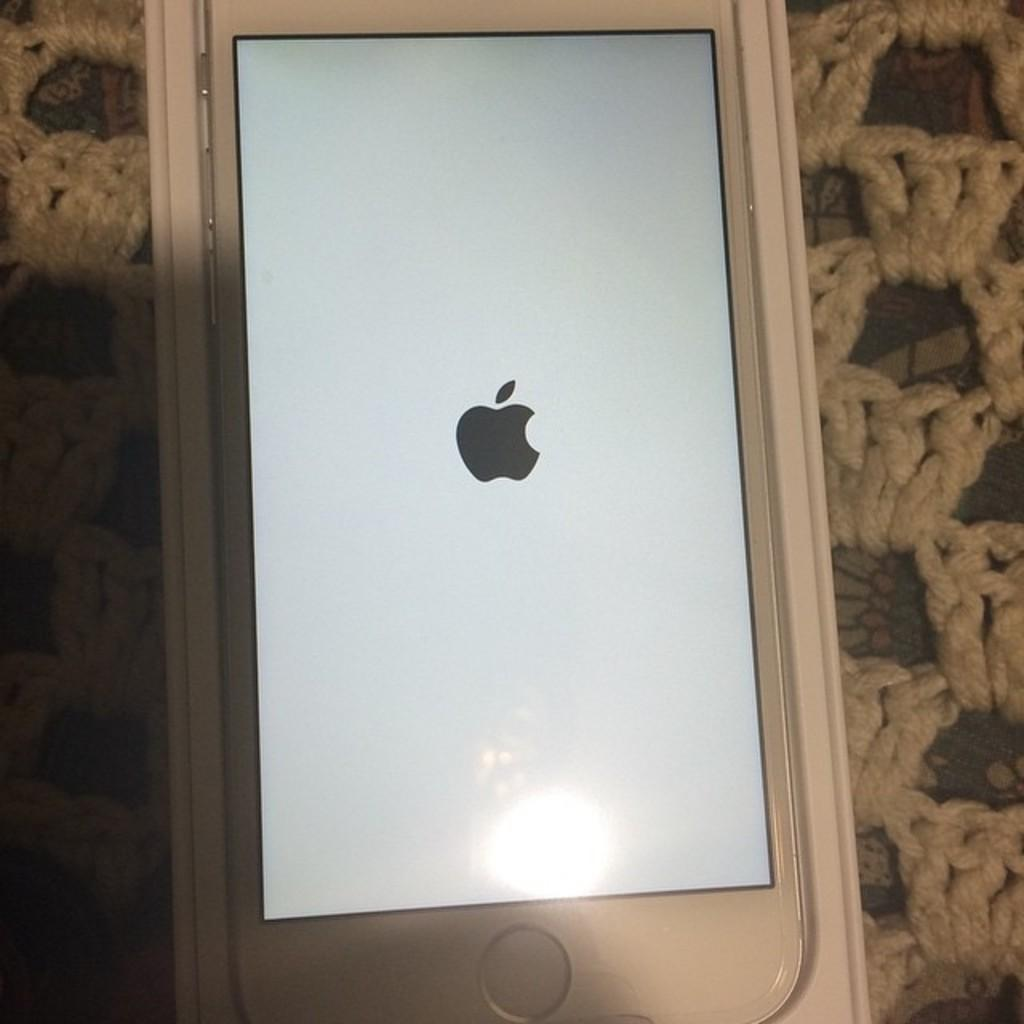What color is the phone in the image? The phone in the image is white-colored. What is displayed on the phone's screen? The phone's screen displays a black-colored logo in the center. How many twigs are used to balance the phone in the image? There are no twigs present in the image, and the phone is not being balanced. 